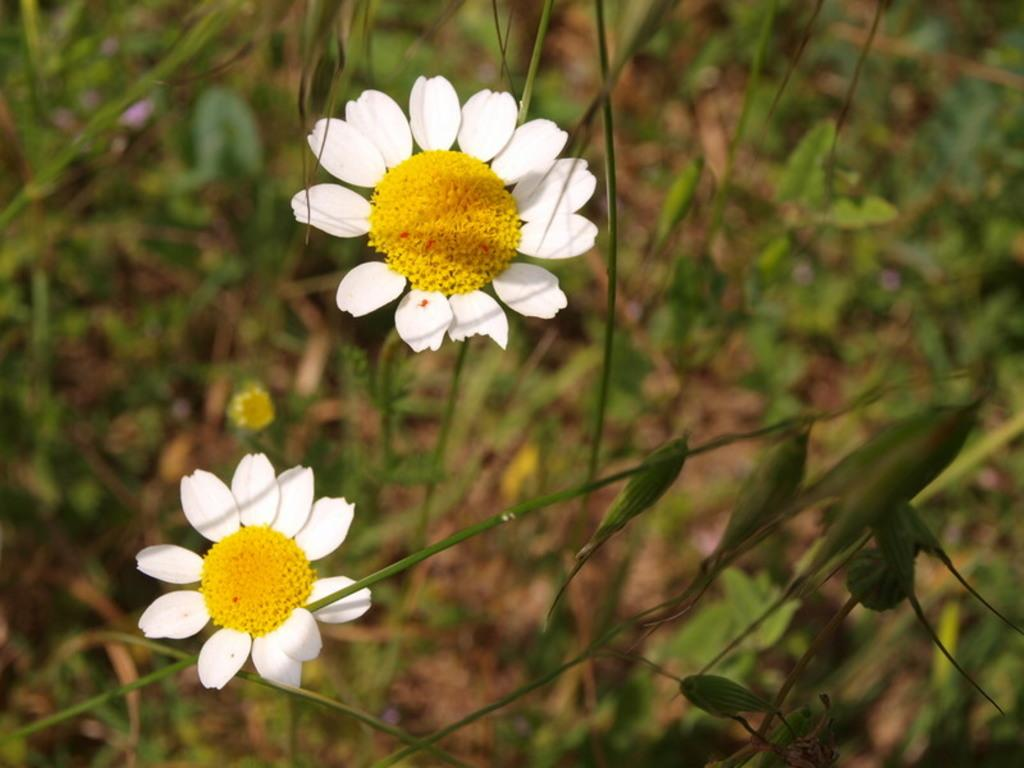What type of plants can be seen in the image? There are flowers, stems, and leaves in the image. What part of the plants are visible in the image? The flowers, stems, and leaves are visible in the image. How would you describe the background of the image? The background of the image is blurred. What type of soap is being used to create peace in the image? There is no soap or reference to peace in the image; it features flowers, stems, leaves, and a blurred background. 